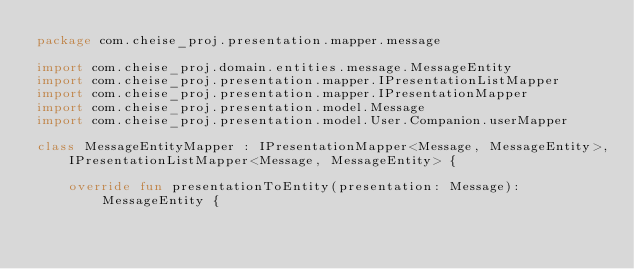Convert code to text. <code><loc_0><loc_0><loc_500><loc_500><_Kotlin_>package com.cheise_proj.presentation.mapper.message

import com.cheise_proj.domain.entities.message.MessageEntity
import com.cheise_proj.presentation.mapper.IPresentationListMapper
import com.cheise_proj.presentation.mapper.IPresentationMapper
import com.cheise_proj.presentation.model.Message
import com.cheise_proj.presentation.model.User.Companion.userMapper

class MessageEntityMapper : IPresentationMapper<Message, MessageEntity>,
    IPresentationListMapper<Message, MessageEntity> {

    override fun presentationToEntity(presentation: Message): MessageEntity {</code> 